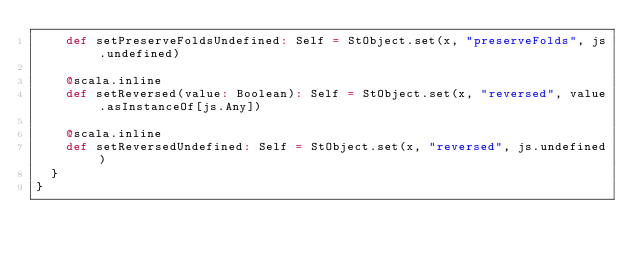Convert code to text. <code><loc_0><loc_0><loc_500><loc_500><_Scala_>    def setPreserveFoldsUndefined: Self = StObject.set(x, "preserveFolds", js.undefined)
    
    @scala.inline
    def setReversed(value: Boolean): Self = StObject.set(x, "reversed", value.asInstanceOf[js.Any])
    
    @scala.inline
    def setReversedUndefined: Self = StObject.set(x, "reversed", js.undefined)
  }
}
</code> 